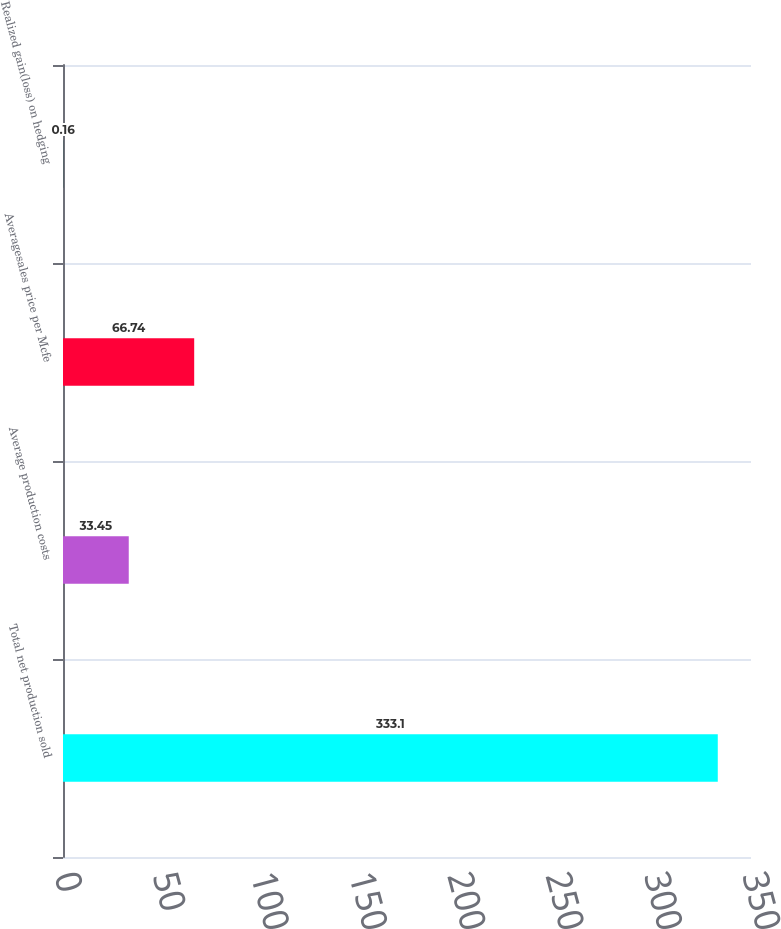Convert chart to OTSL. <chart><loc_0><loc_0><loc_500><loc_500><bar_chart><fcel>Total net production sold<fcel>Average production costs<fcel>Averagesales price per Mcfe<fcel>Realized gain(loss) on hedging<nl><fcel>333.1<fcel>33.45<fcel>66.74<fcel>0.16<nl></chart> 